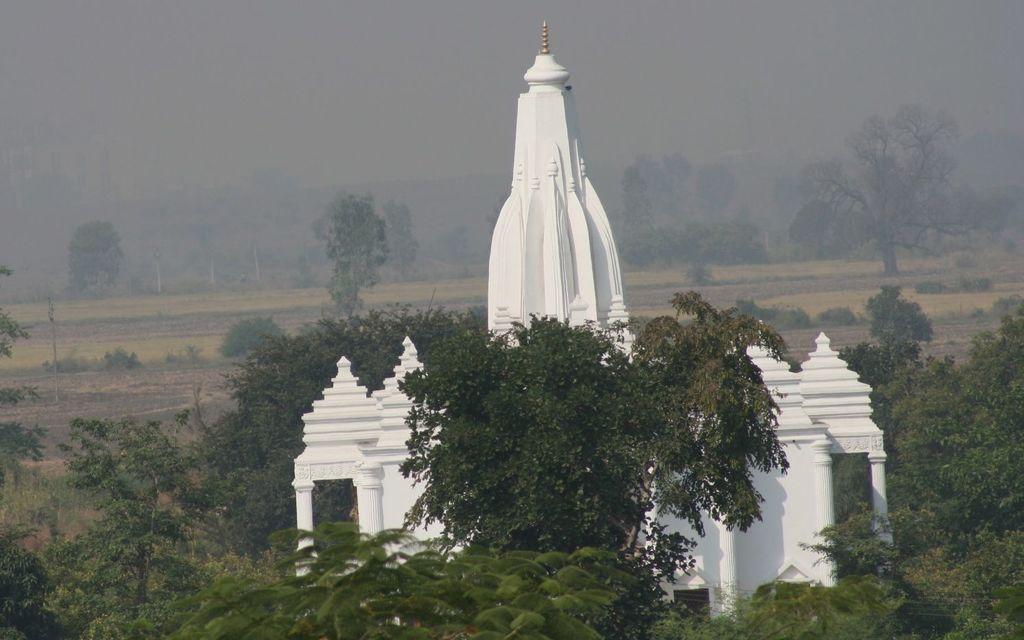Please provide a concise description of this image. This image consists of a temple in white color. At the bottom, there are plants and trees. In the background, there is a ground. 